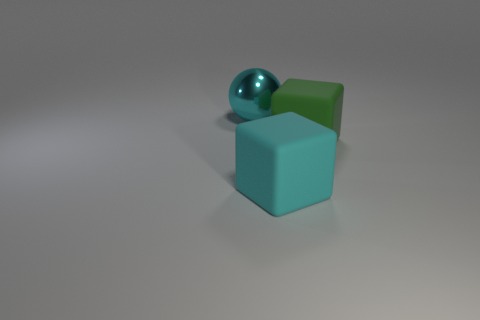Add 1 big metallic balls. How many objects exist? 4 Subtract all cubes. How many objects are left? 1 Add 3 small red rubber blocks. How many small red rubber blocks exist? 3 Subtract 0 yellow spheres. How many objects are left? 3 Subtract all big red metallic balls. Subtract all matte cubes. How many objects are left? 1 Add 3 big green rubber objects. How many big green rubber objects are left? 4 